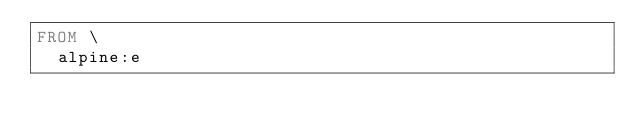Convert code to text. <code><loc_0><loc_0><loc_500><loc_500><_Dockerfile_>FROM \
  alpine:e
</code> 